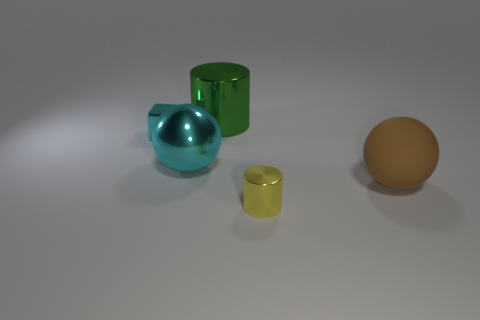Add 4 big green metal things. How many objects exist? 9 Subtract 1 balls. How many balls are left? 1 Subtract 0 purple cylinders. How many objects are left? 5 Subtract all balls. How many objects are left? 3 Subtract all blue cylinders. Subtract all blue balls. How many cylinders are left? 2 Subtract all purple cubes. How many yellow balls are left? 0 Subtract all tiny yellow objects. Subtract all metal cubes. How many objects are left? 3 Add 4 small yellow metallic cylinders. How many small yellow metallic cylinders are left? 5 Add 5 tiny brown blocks. How many tiny brown blocks exist? 5 